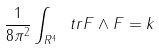Convert formula to latex. <formula><loc_0><loc_0><loc_500><loc_500>\frac { 1 } { 8 \pi ^ { 2 } } \int _ { R ^ { 4 } } \ t r F \wedge F = k</formula> 